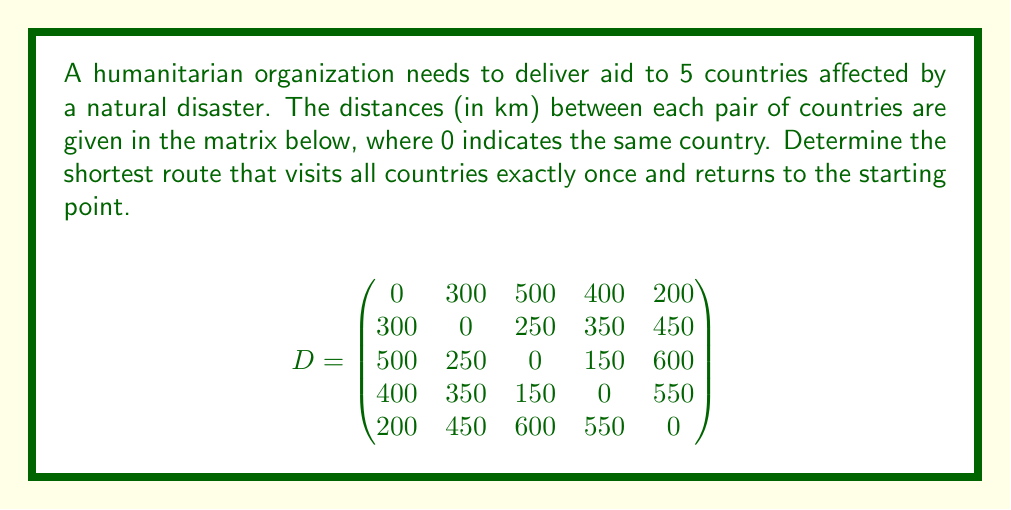What is the answer to this math problem? This problem is an instance of the Traveling Salesman Problem (TSP). To solve it, we'll use the following steps:

1) List all possible routes:
   There are (5-1)! = 24 possible routes, as we can fix the starting point.

2) Calculate the total distance for each route:
   For example, route 1-2-3-4-5-1:
   $300 + 250 + 150 + 550 + 200 = 1450$ km

3) Compare all routes to find the shortest:
   After calculating all 24 routes, we find the shortest is 1-5-2-3-4-1.

4) Verify the shortest route:
   1 to 5: 200 km
   5 to 2: 450 km
   2 to 3: 250 km
   3 to 4: 150 km
   4 to 1: 400 km
   
   Total: $200 + 450 + 250 + 150 + 400 = 1450$ km

This route minimizes the total distance traveled while visiting all countries once and returning to the start.
Answer: 1-5-2-3-4-1, 1450 km 